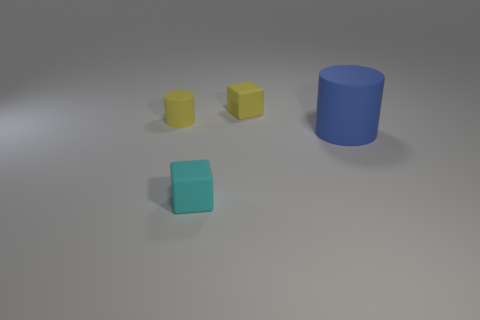How many things have the same color as the small rubber cylinder?
Provide a short and direct response. 1. There is a tiny block that is behind the tiny cyan cube; does it have the same color as the tiny cylinder?
Offer a very short reply. Yes. Is the number of tiny things greater than the number of yellow matte objects?
Offer a very short reply. Yes. How many small cyan blocks are there?
Ensure brevity in your answer.  1. The tiny yellow object that is on the left side of the tiny matte cube on the right side of the cube in front of the blue cylinder is what shape?
Provide a short and direct response. Cylinder. Are there fewer cyan rubber things that are behind the large cylinder than rubber things in front of the yellow rubber cylinder?
Give a very brief answer. Yes. Is the shape of the small yellow matte object that is on the right side of the yellow cylinder the same as the thing in front of the blue matte thing?
Offer a terse response. Yes. What shape is the tiny object that is on the left side of the small rubber block that is in front of the blue object?
Your response must be concise. Cylinder. Is there a tiny purple block that has the same material as the big blue cylinder?
Give a very brief answer. No. There is a yellow object left of the yellow block; what is it made of?
Keep it short and to the point. Rubber. 